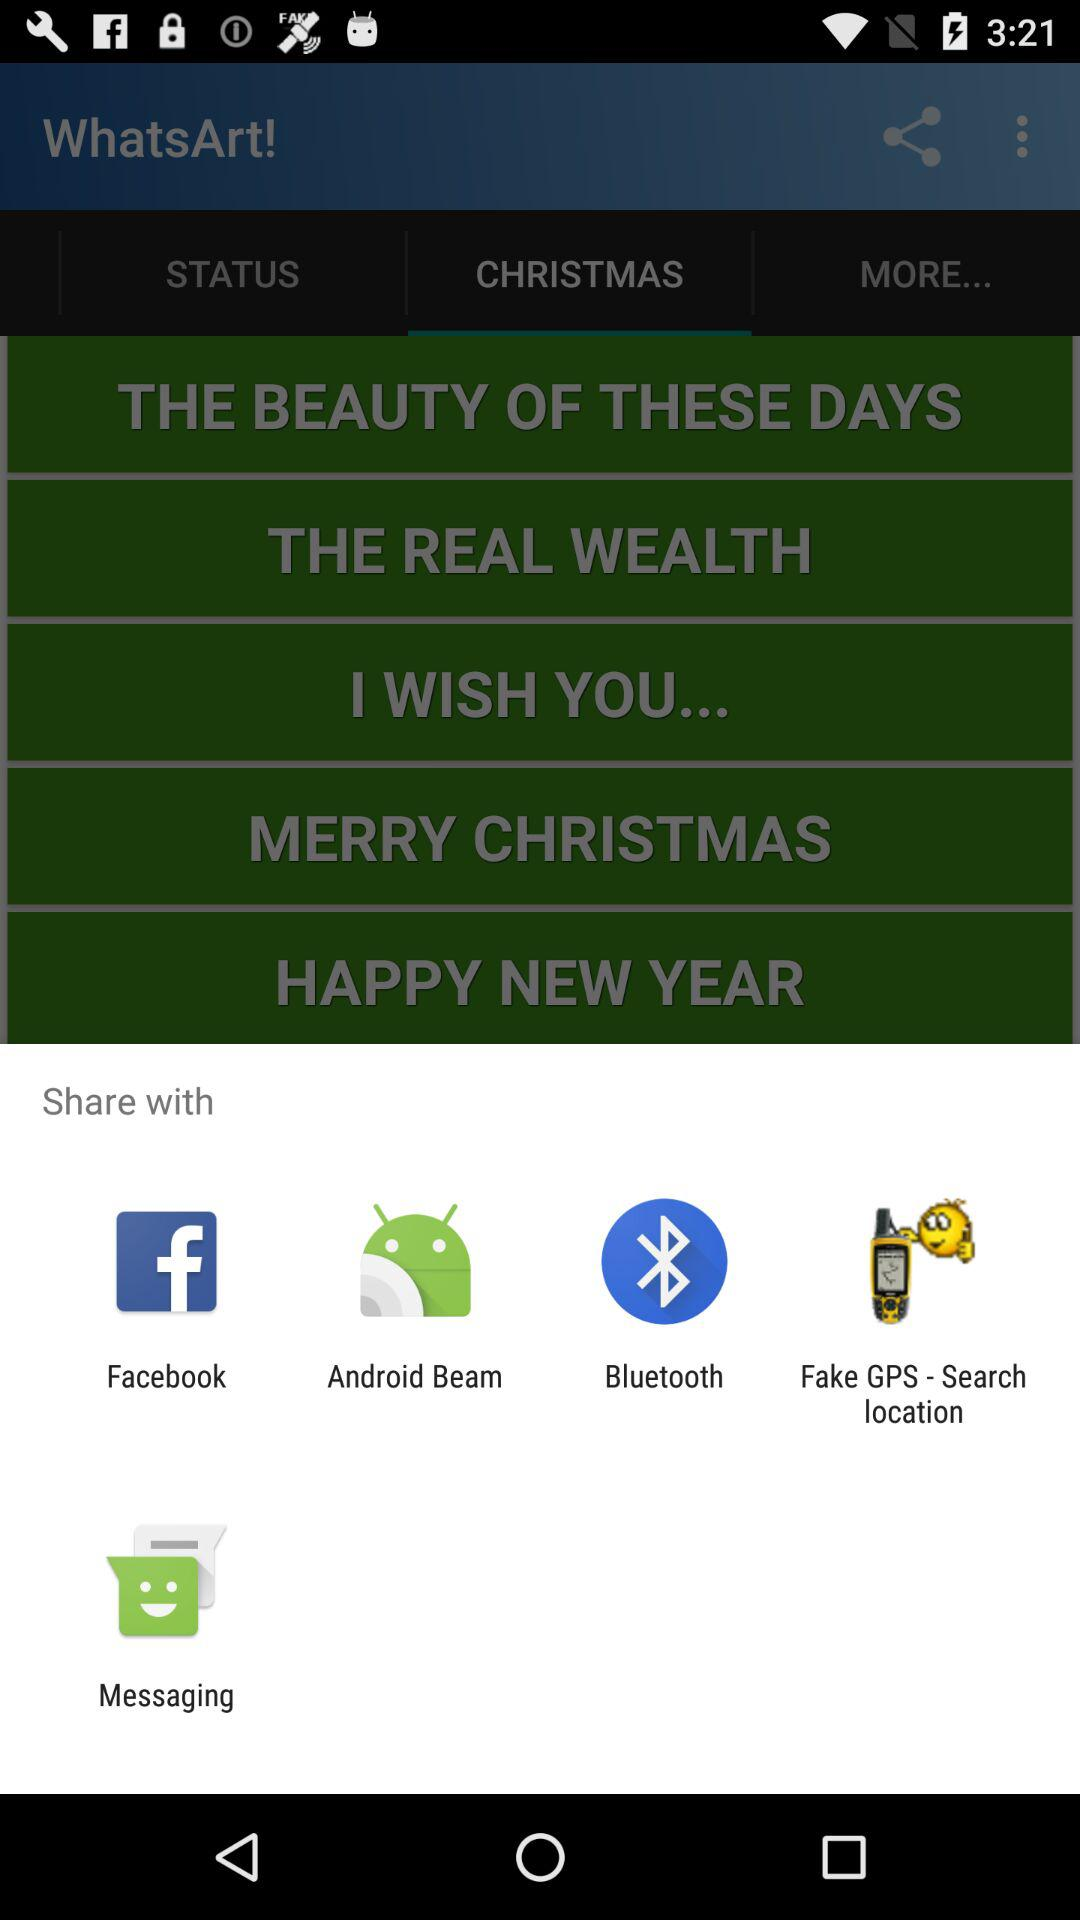Which application can be used to share? The applications that can be used to share are "Facebook", "Android Beam", "Bluetooth", "Fake GPS - Search location" and "Messaging". 